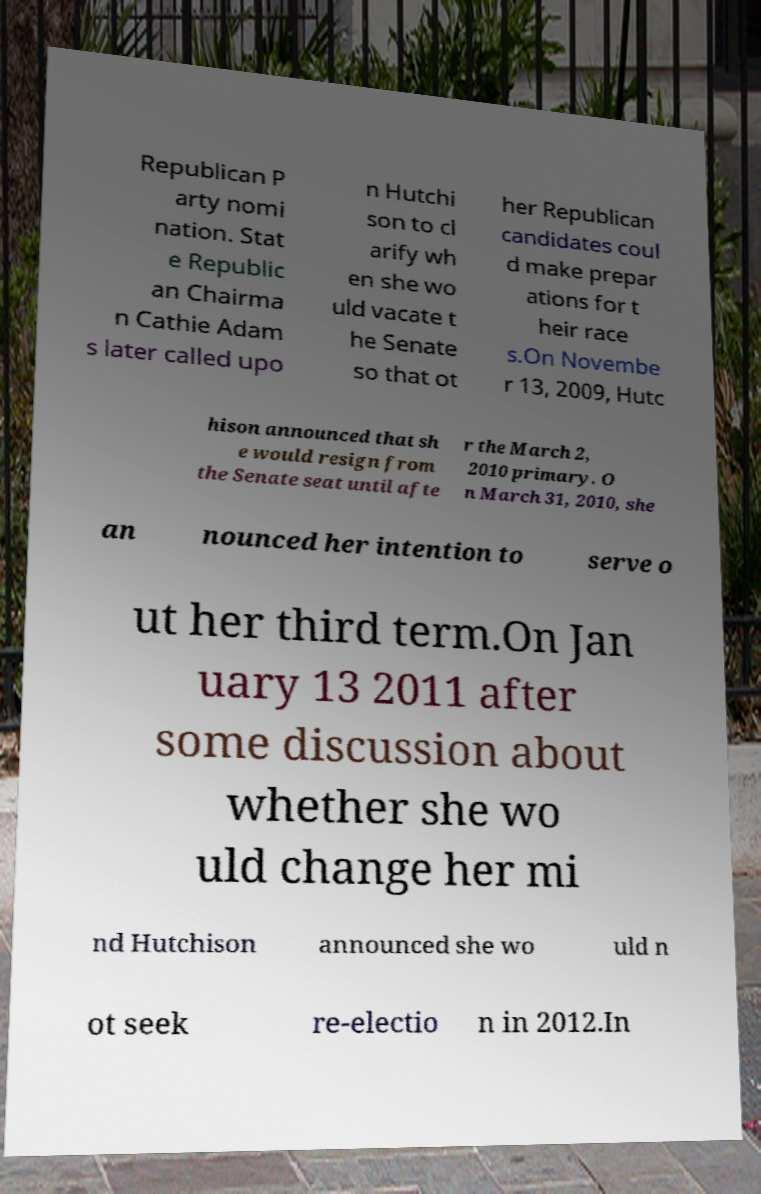Could you assist in decoding the text presented in this image and type it out clearly? Republican P arty nomi nation. Stat e Republic an Chairma n Cathie Adam s later called upo n Hutchi son to cl arify wh en she wo uld vacate t he Senate so that ot her Republican candidates coul d make prepar ations for t heir race s.On Novembe r 13, 2009, Hutc hison announced that sh e would resign from the Senate seat until afte r the March 2, 2010 primary. O n March 31, 2010, she an nounced her intention to serve o ut her third term.On Jan uary 13 2011 after some discussion about whether she wo uld change her mi nd Hutchison announced she wo uld n ot seek re-electio n in 2012.In 